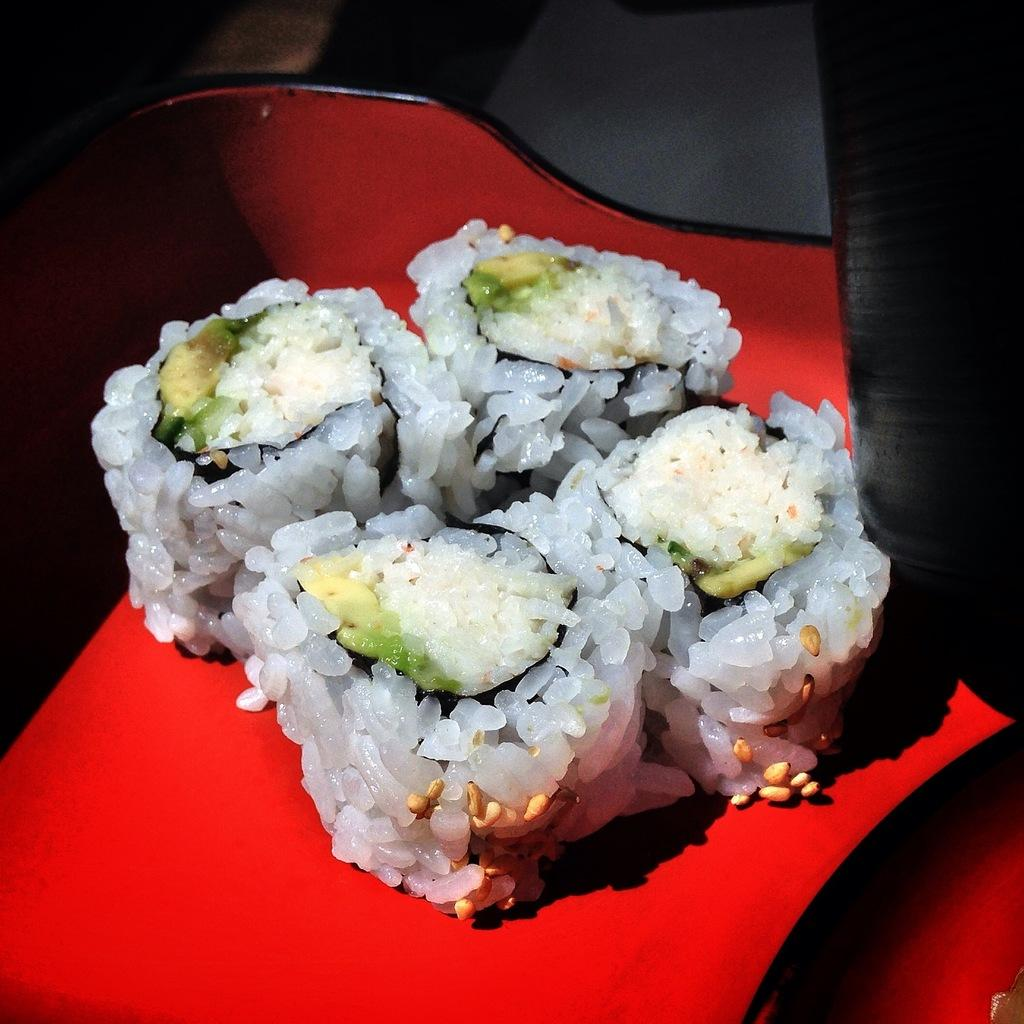What is the color of the platform on which the food is placed in the image? The platform is red. What is located on the red platform in the image? There is food on the red platform. Can you describe the background of the image? The background of the image is not clear. How many fingers can be seen pointing at the food in the image? There are no fingers visible in the image, so it is not possible to determine how many fingers might be pointing at the food. 